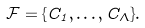<formula> <loc_0><loc_0><loc_500><loc_500>\mathcal { F } = \{ C _ { 1 } , \dots , C _ { \Lambda } \} .</formula> 